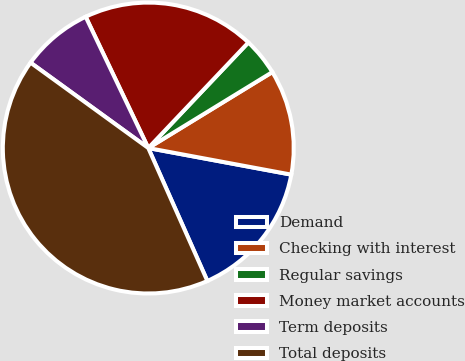<chart> <loc_0><loc_0><loc_500><loc_500><pie_chart><fcel>Demand<fcel>Checking with interest<fcel>Regular savings<fcel>Money market accounts<fcel>Term deposits<fcel>Total deposits<nl><fcel>15.42%<fcel>11.67%<fcel>4.18%<fcel>19.16%<fcel>7.93%<fcel>41.64%<nl></chart> 